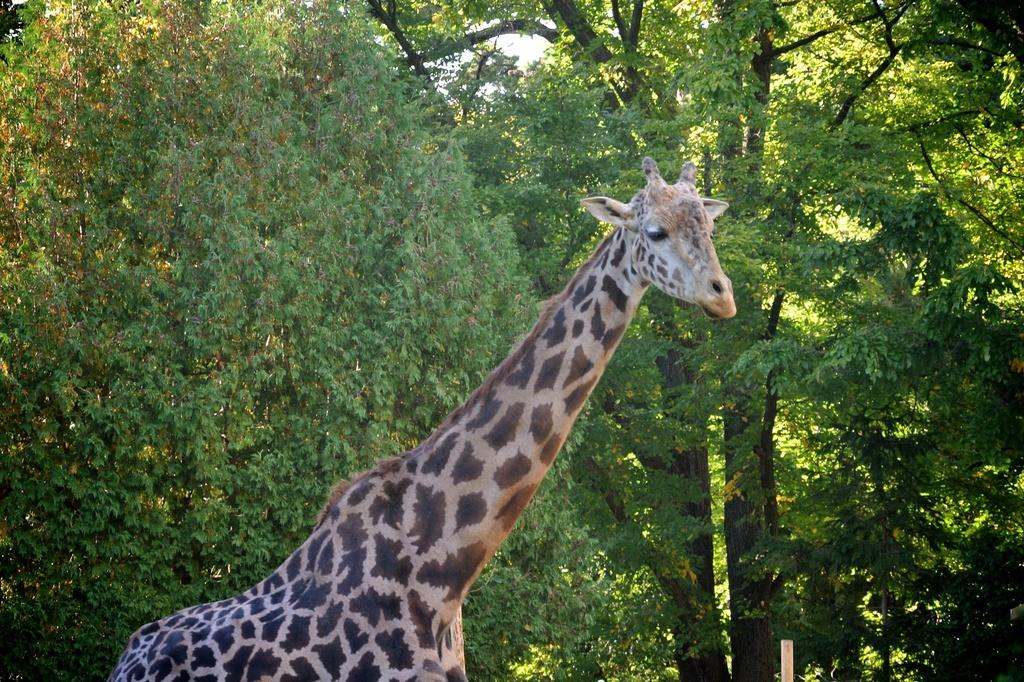What type of animal is in the image? There is a giraffe in the image. What can be seen in the background of the image? There are trees in the image. What type of rail is visible in the image? There is no rail present in the image; it features a giraffe and trees. Is there a ring on the giraffe's neck in the image? No, there is no ring on the giraffe's neck in the image. 